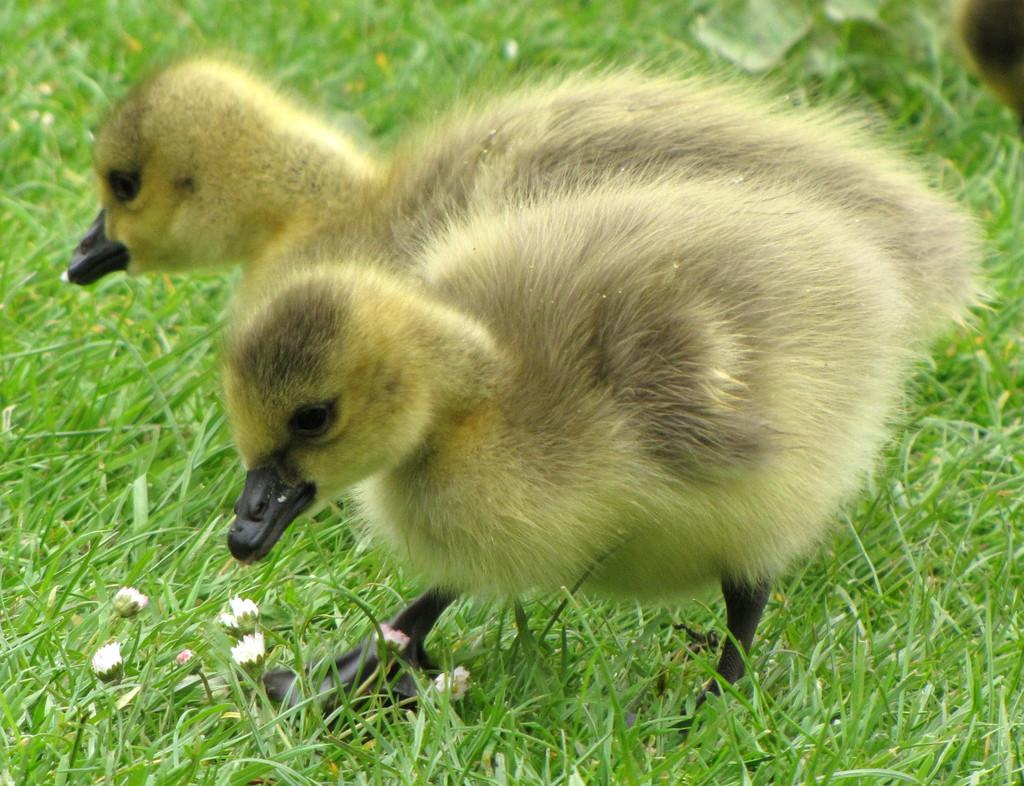What animals can be seen in the image? There are two ducks in the image. Where are the ducks located? The ducks are on the grass. What type of vegetation is present in the image? There are tiny flowers in the image. What type of wool can be seen on the ducks in the image? There is no wool present on the ducks in the image; they are not wearing any clothing or accessories. 